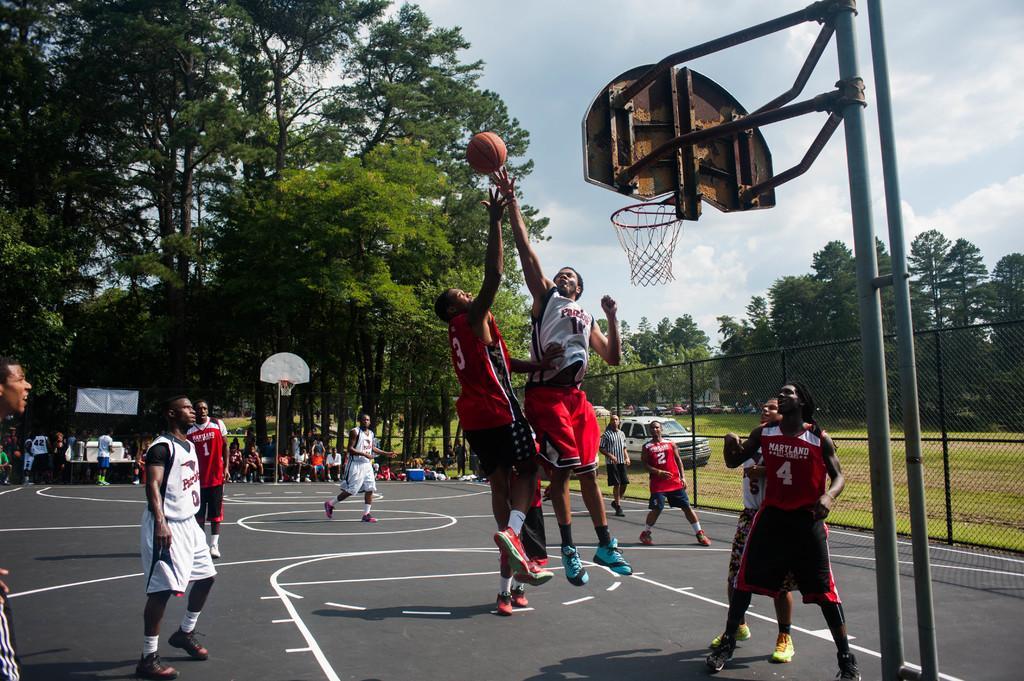Describe this image in one or two sentences. In this image it seems like there are few players who are playing the basket ball. On the right side there is a goal post. In the background there are few people sitting and watching the game. On the right side there is a fence. Behind the fence there is a car in the ground. In the background there are trees. 